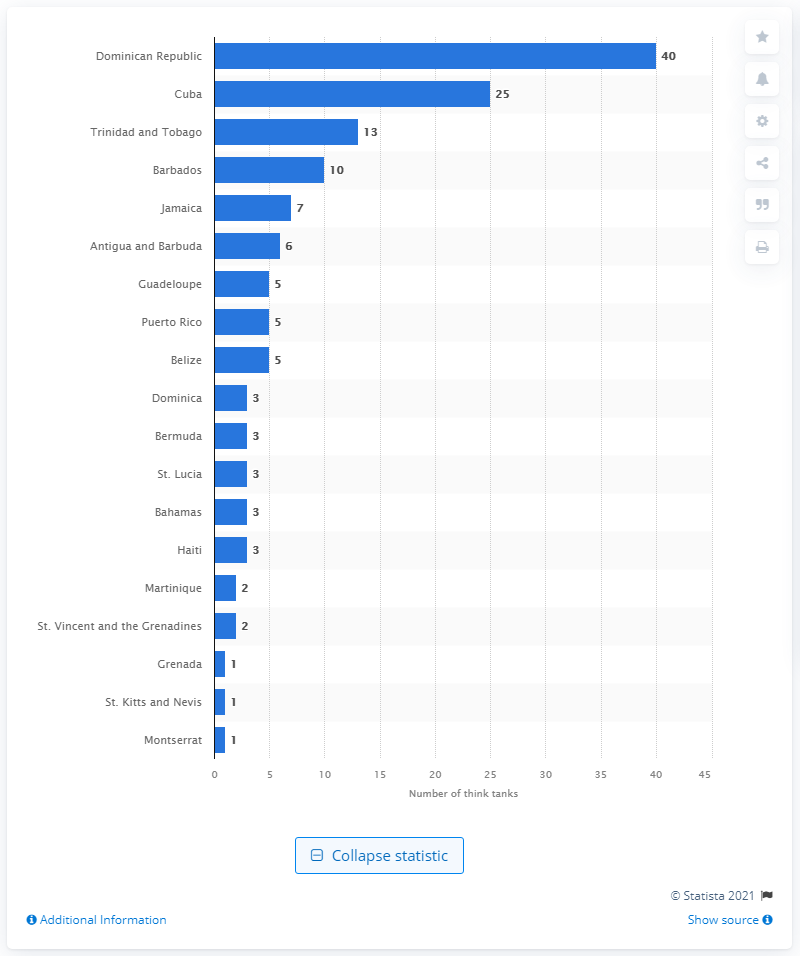Draw attention to some important aspects in this diagram. As of 2018, the Dominican Republic had approximately 40 think tanks. As of 2018, it is estimated that Cuba had approximately 25 think tanks. 